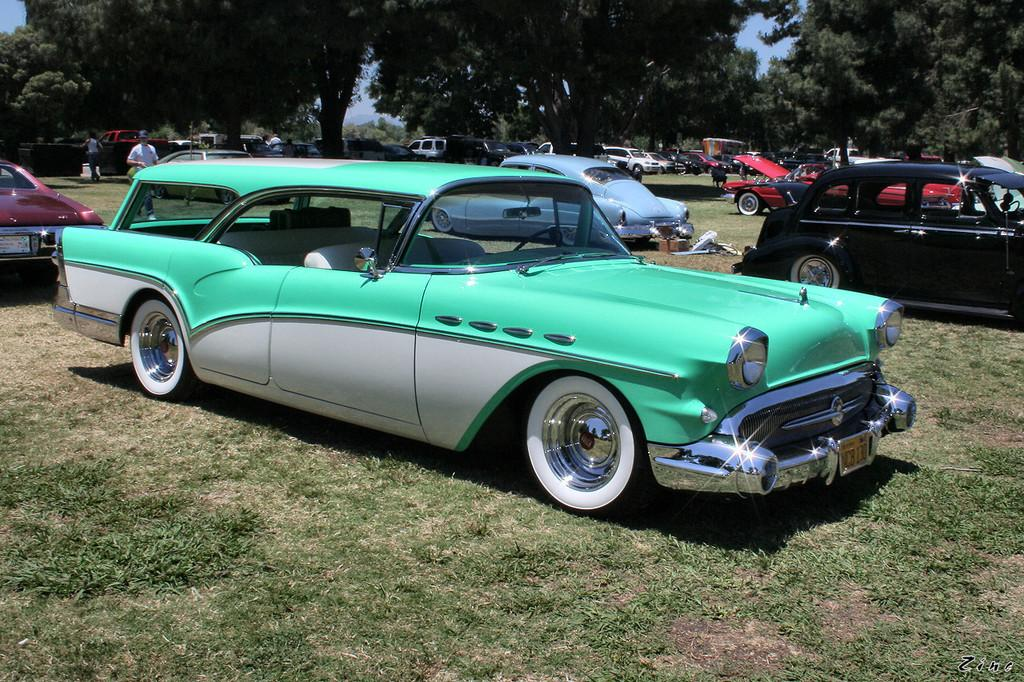What type of vehicles can be seen in the image? There are cars in the image. Who or what else is present in the image? There are people in the image. What type of vegetation is at the bottom of the image? There is grass at the bottom of the image. What can be seen in the background of the image? There are trees and the sky visible in the background of the image. How many dust particles can be seen on the cars in the image? There is no information about dust particles on the cars in the image, so it cannot be determined. Is there a girl in the image interacting with the trees? There is no girl present in the image, so it cannot be determined if she is interacting with the trees. 